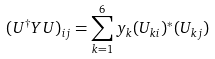Convert formula to latex. <formula><loc_0><loc_0><loc_500><loc_500>( U ^ { \dag } Y U ) _ { i j } = \sum _ { k = 1 } ^ { 6 } y _ { k } ( U _ { k i } ) ^ { * } ( U _ { k j } )</formula> 